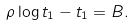<formula> <loc_0><loc_0><loc_500><loc_500>\rho \log t _ { 1 } - t _ { 1 } = B .</formula> 